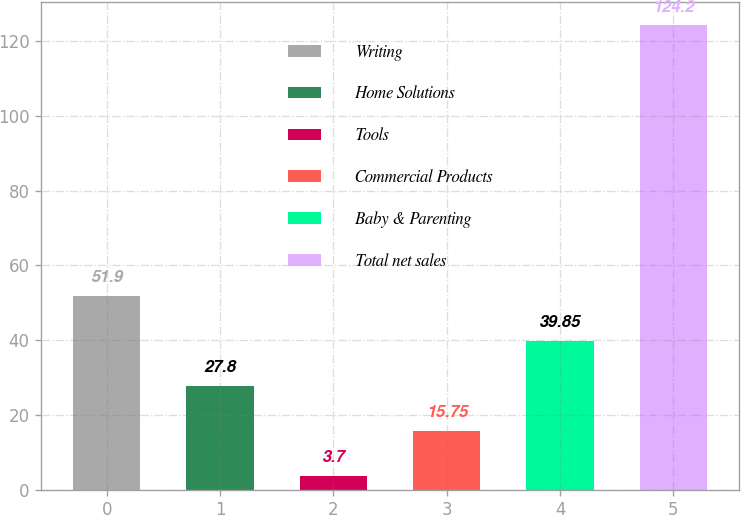Convert chart. <chart><loc_0><loc_0><loc_500><loc_500><bar_chart><fcel>Writing<fcel>Home Solutions<fcel>Tools<fcel>Commercial Products<fcel>Baby & Parenting<fcel>Total net sales<nl><fcel>51.9<fcel>27.8<fcel>3.7<fcel>15.75<fcel>39.85<fcel>124.2<nl></chart> 